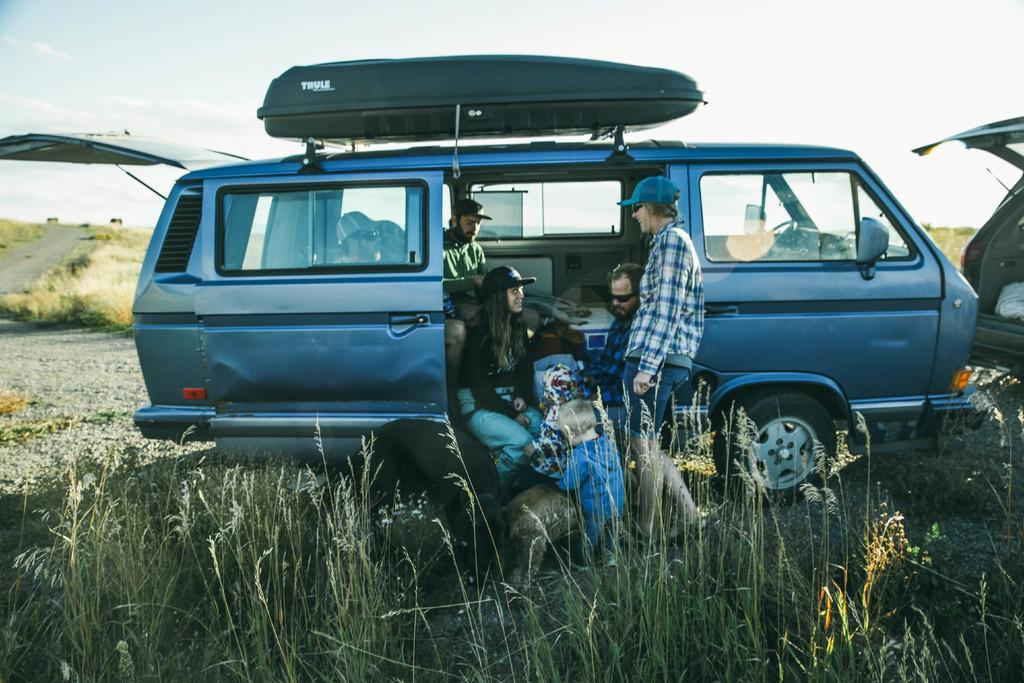How would you summarize this image in a sentence or two? Here we can see few persons and there are vehicles on the ground. There is a road. Here we can see grass. In the background there is sky. 